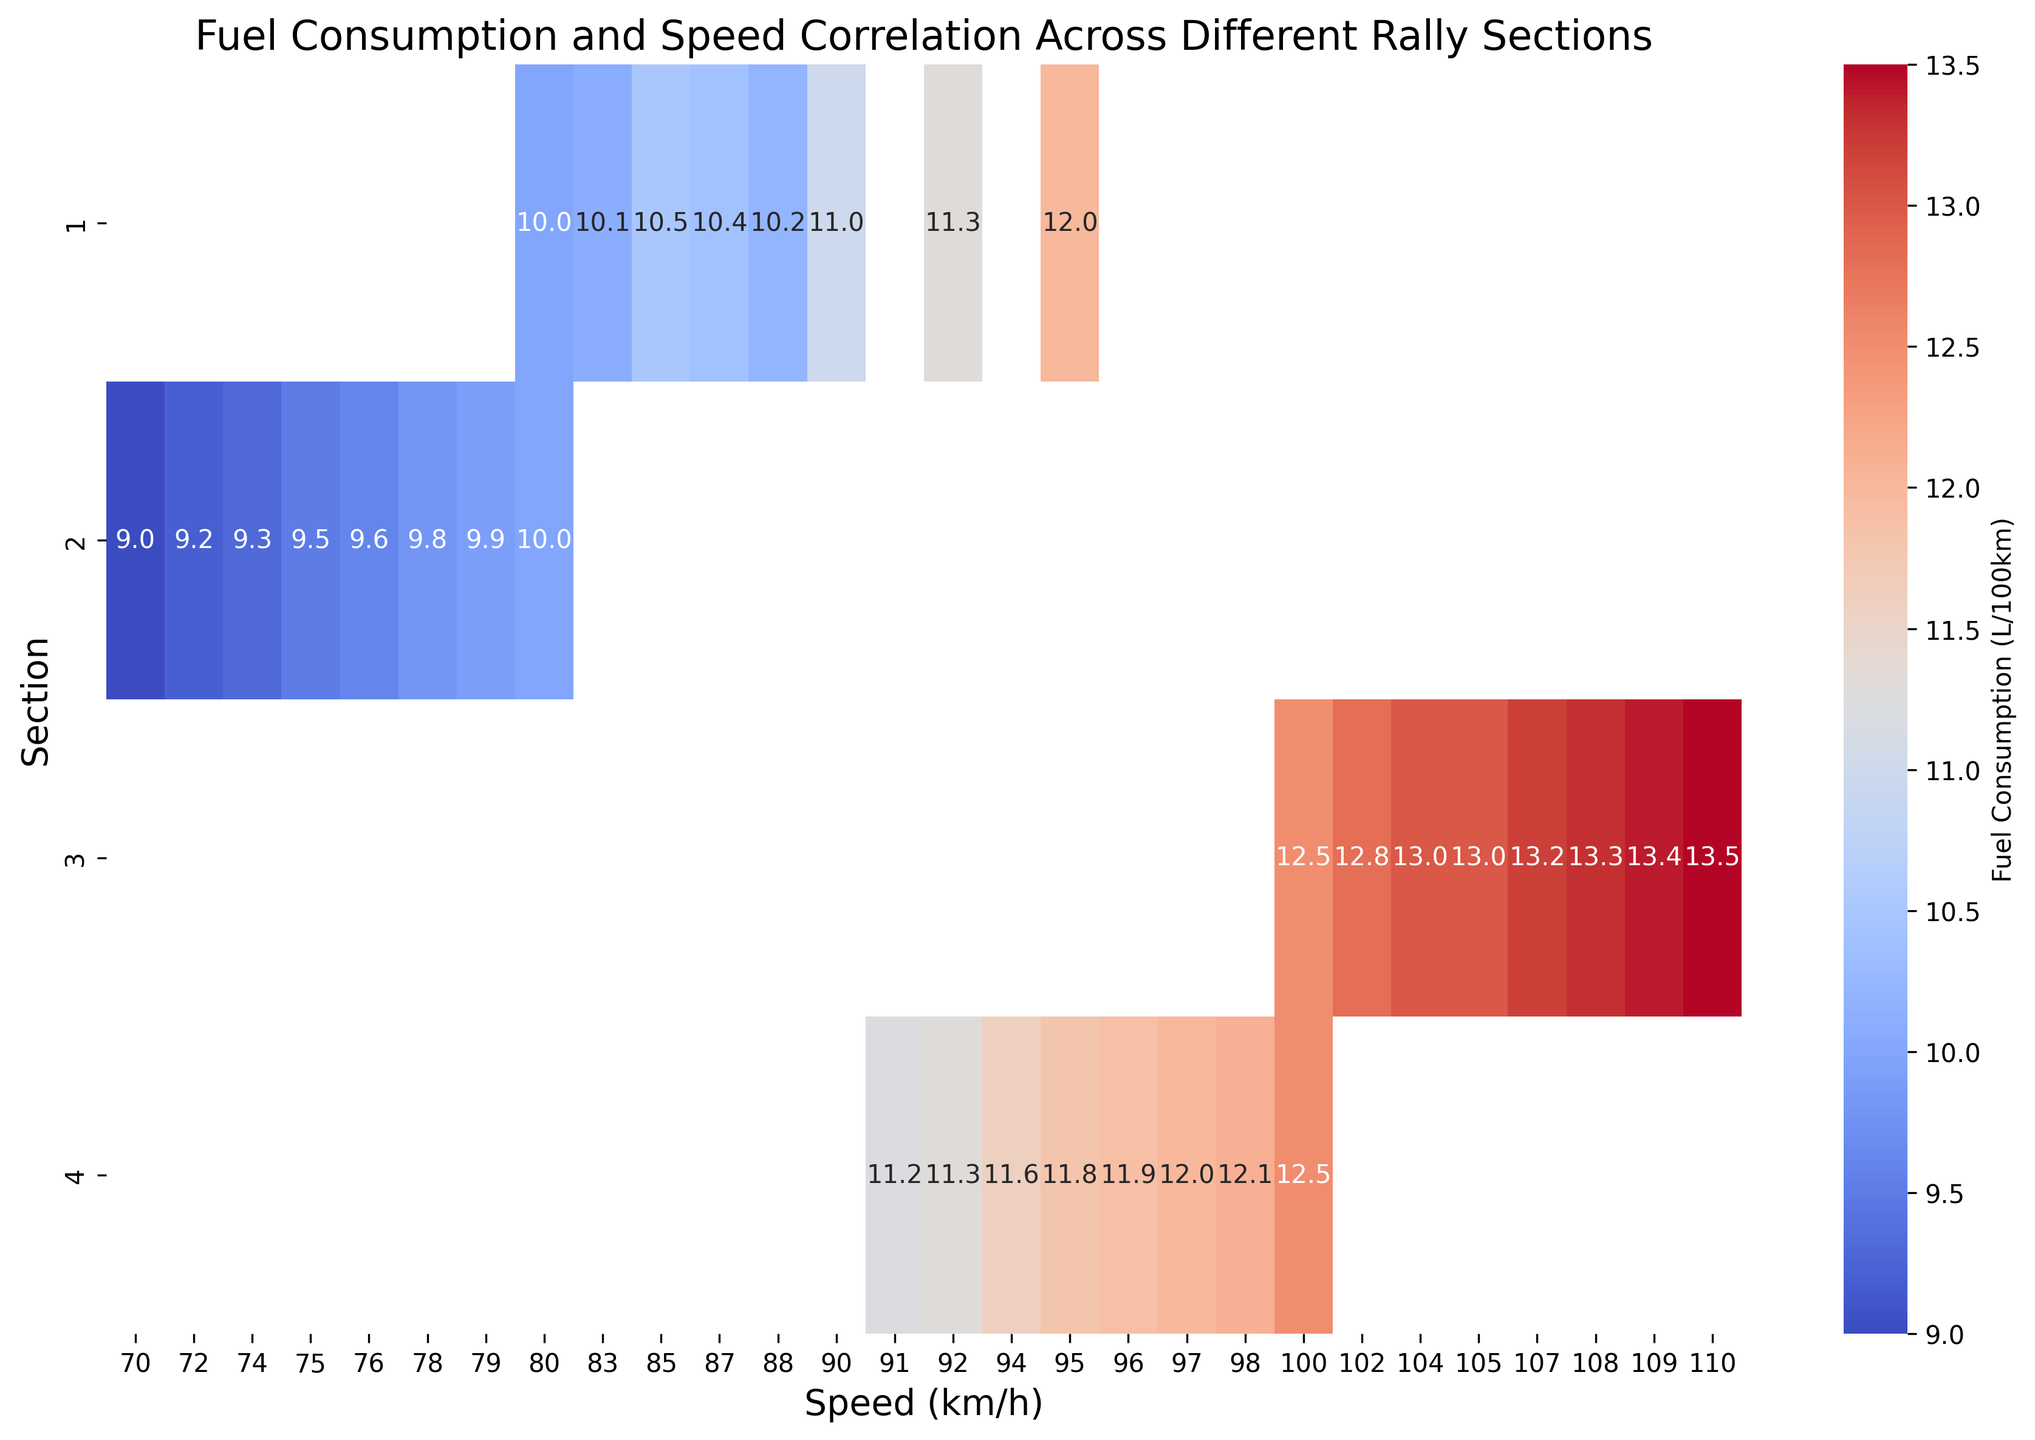What is the fuel consumption at a speed of 100 km/h in section 4? Identify the cell where section 4 intersects with 100 km/h and read the annotated fuel consumption value.
Answer: 12.5 Between which two sections is the difference in fuel consumption the largest at 95 km/h? Compare the annotated fuel consumption values at 95 km/h for all sections and identify the two sections with the largest difference.
Answer: Section 1 and Section 4 What is the average fuel consumption in section 3? Locate section 3 and find the average of all the annotated fuel consumption values in that row. Calculate (12.5 + 13 + 13.5 + 13.3 + 12.8 + 13.2 + 13 + 13.4) / 8.
Answer: 13.1 Which section has the lowest fuel consumption at a speed of 80 km/h? Compare the annotated fuel consumption values at 80 km/h for all sections and identify the section with the lowest value.
Answer: Section 2 How does fuel consumption change as speed increases in section 1? Observe the trend in the annotated fuel consumption values as the speed increases in section 1.
Answer: Increases Which section shows the greatest range of fuel consumption values? Evaluate the difference between the highest and lowest annotated fuel consumption values in each section and identify the section with the greatest range.
Answer: Section 4 At what speed does section 2 have the highest fuel consumption? Look at the annotated fuel consumption values for section 2 and find the speed with the highest value.
Answer: 80 km/h Compare the fuel consumption at 90 km/h between section 1 and section 4. Which one is higher? Identify the annotated values for 90 km/h in sections 1 and 4 and compare them.
Answer: Section 1 What is the median fuel consumption value for section 3? Arrange the annotated fuel consumption values for section 3 in ascending order and find the middle value. Since there are 8 values, the median will be the average of the 4th and 5th values: (13 + 13.2) / 2.
Answer: 13.1 Between section 2 and section 4, which one has more consistent fuel consumption values? Compare the variability in the annotated fuel consumption values for sections 2 and 4. Generally, less variability means more consistency.
Answer: Section 2 